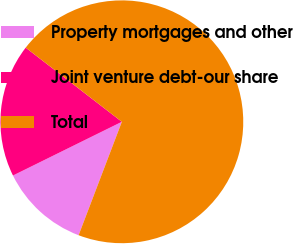<chart> <loc_0><loc_0><loc_500><loc_500><pie_chart><fcel>Property mortgages and other<fcel>Joint venture debt-our share<fcel>Total<nl><fcel>11.91%<fcel>17.75%<fcel>70.34%<nl></chart> 